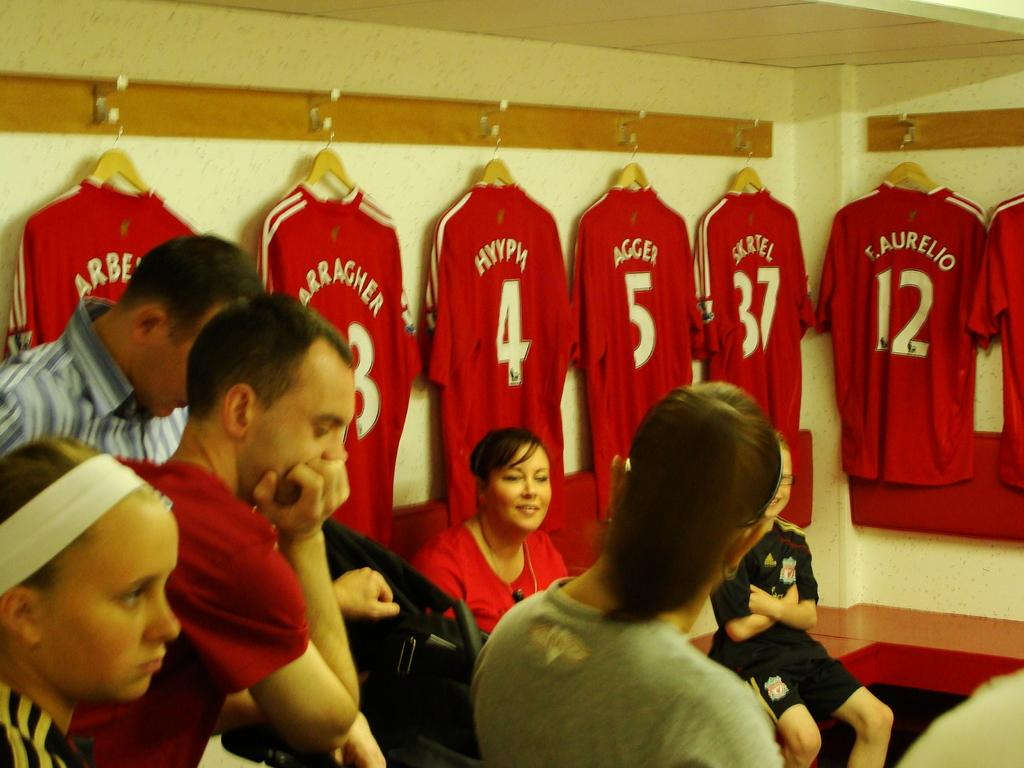<image>
Provide a brief description of the given image. The player with the number four jersey is called Hypn 